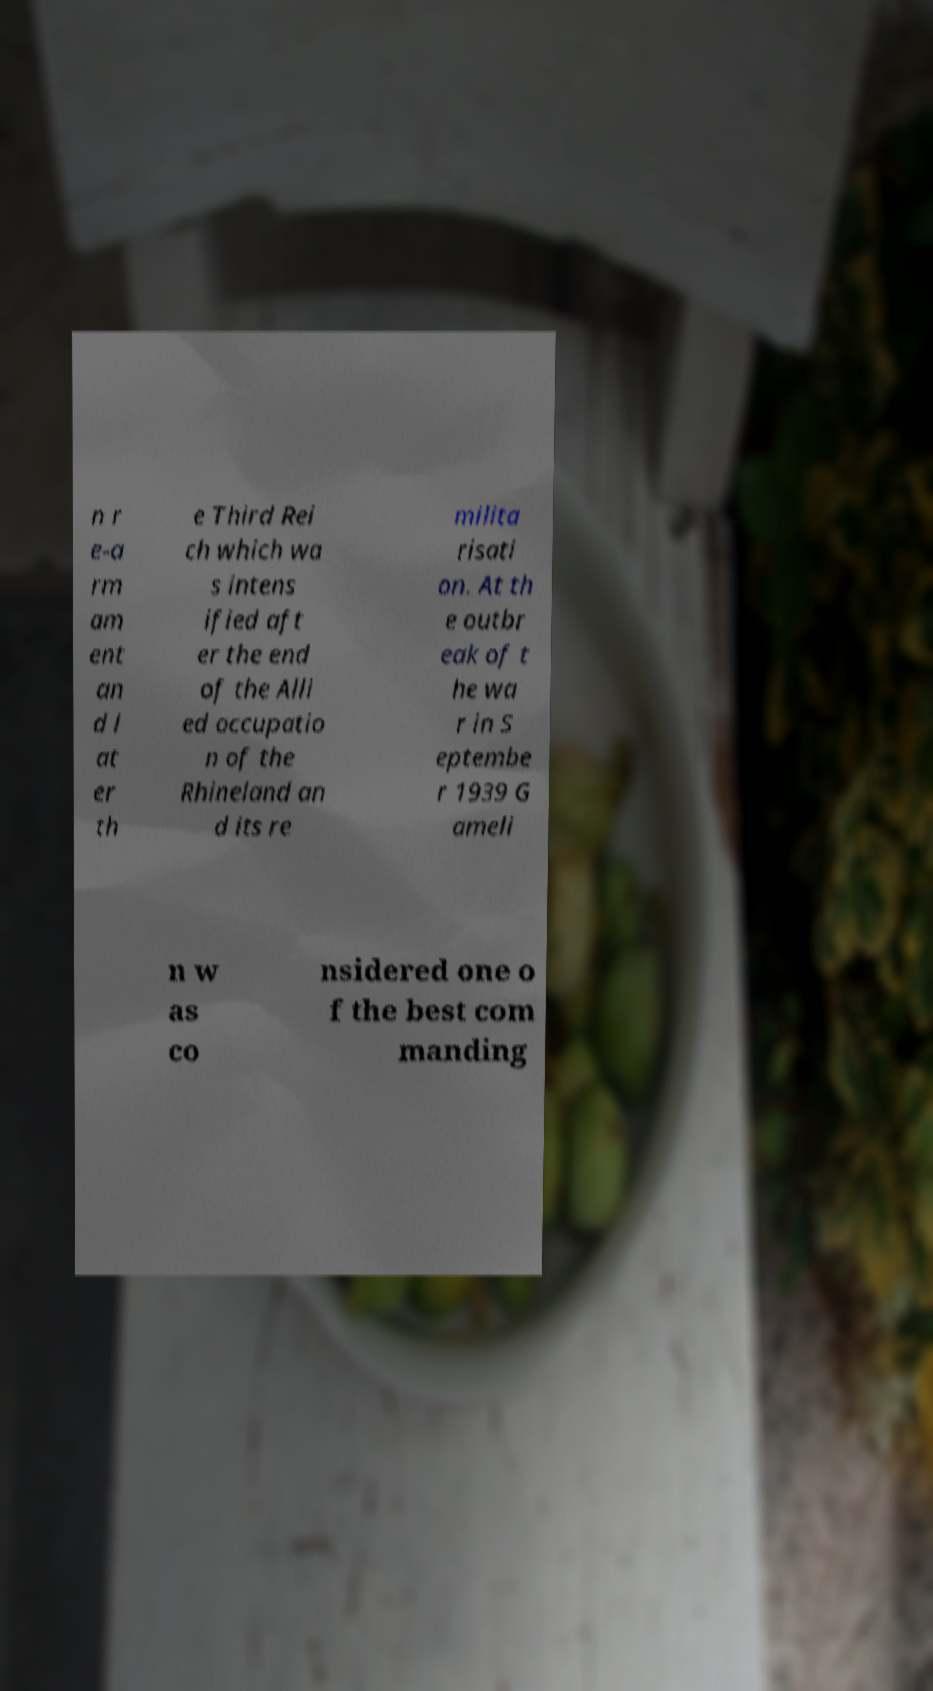Please identify and transcribe the text found in this image. n r e-a rm am ent an d l at er th e Third Rei ch which wa s intens ified aft er the end of the Alli ed occupatio n of the Rhineland an d its re milita risati on. At th e outbr eak of t he wa r in S eptembe r 1939 G ameli n w as co nsidered one o f the best com manding 